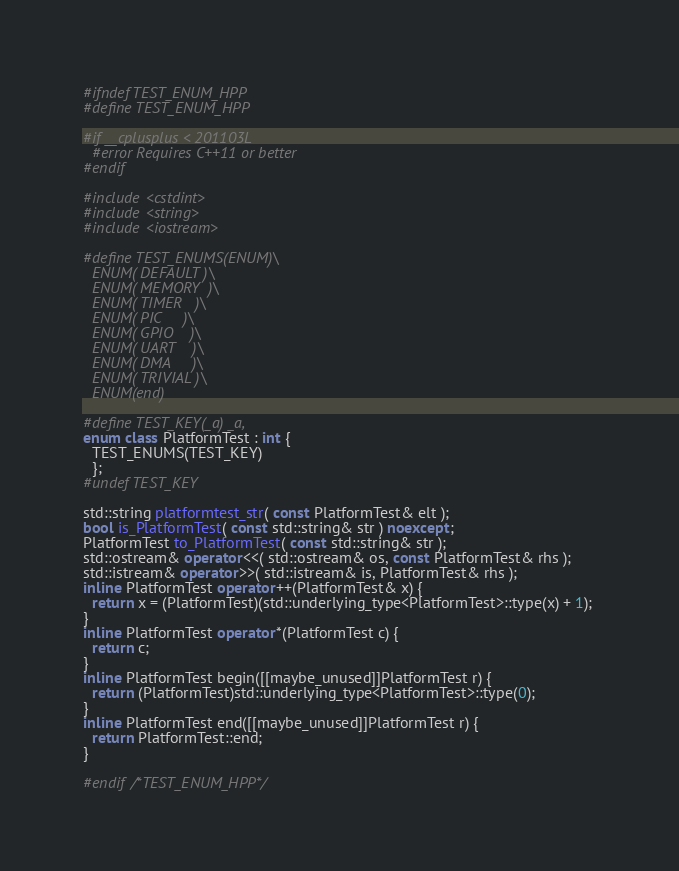Convert code to text. <code><loc_0><loc_0><loc_500><loc_500><_C++_>#ifndef TEST_ENUM_HPP
#define TEST_ENUM_HPP

#if __cplusplus < 201103L
  #error Requires C++11 or better
#endif

#include <cstdint>
#include <string>
#include <iostream>

#define TEST_ENUMS(ENUM)\
  ENUM( DEFAULT )\
  ENUM( MEMORY  )\
  ENUM( TIMER   )\
  ENUM( PIC     )\
  ENUM( GPIO    )\
  ENUM( UART    )\
  ENUM( DMA     )\
  ENUM( TRIVIAL )\
  ENUM(end)

#define TEST_KEY(_a) _a,
enum class PlatformTest : int {
  TEST_ENUMS(TEST_KEY)
  };
#undef TEST_KEY

std::string platformtest_str( const PlatformTest& elt );
bool is_PlatformTest( const std::string& str ) noexcept;
PlatformTest to_PlatformTest( const std::string& str );
std::ostream& operator<<( std::ostream& os, const PlatformTest& rhs );
std::istream& operator>>( std::istream& is, PlatformTest& rhs );
inline PlatformTest operator++(PlatformTest& x) {
  return x = (PlatformTest)(std::underlying_type<PlatformTest>::type(x) + 1); 
}
inline PlatformTest operator*(PlatformTest c) {
  return c;
}
inline PlatformTest begin([[maybe_unused]]PlatformTest r) {
  return (PlatformTest)std::underlying_type<PlatformTest>::type(0);
}
inline PlatformTest end([[maybe_unused]]PlatformTest r) {
  return PlatformTest::end;
}

#endif /*TEST_ENUM_HPP*/
</code> 